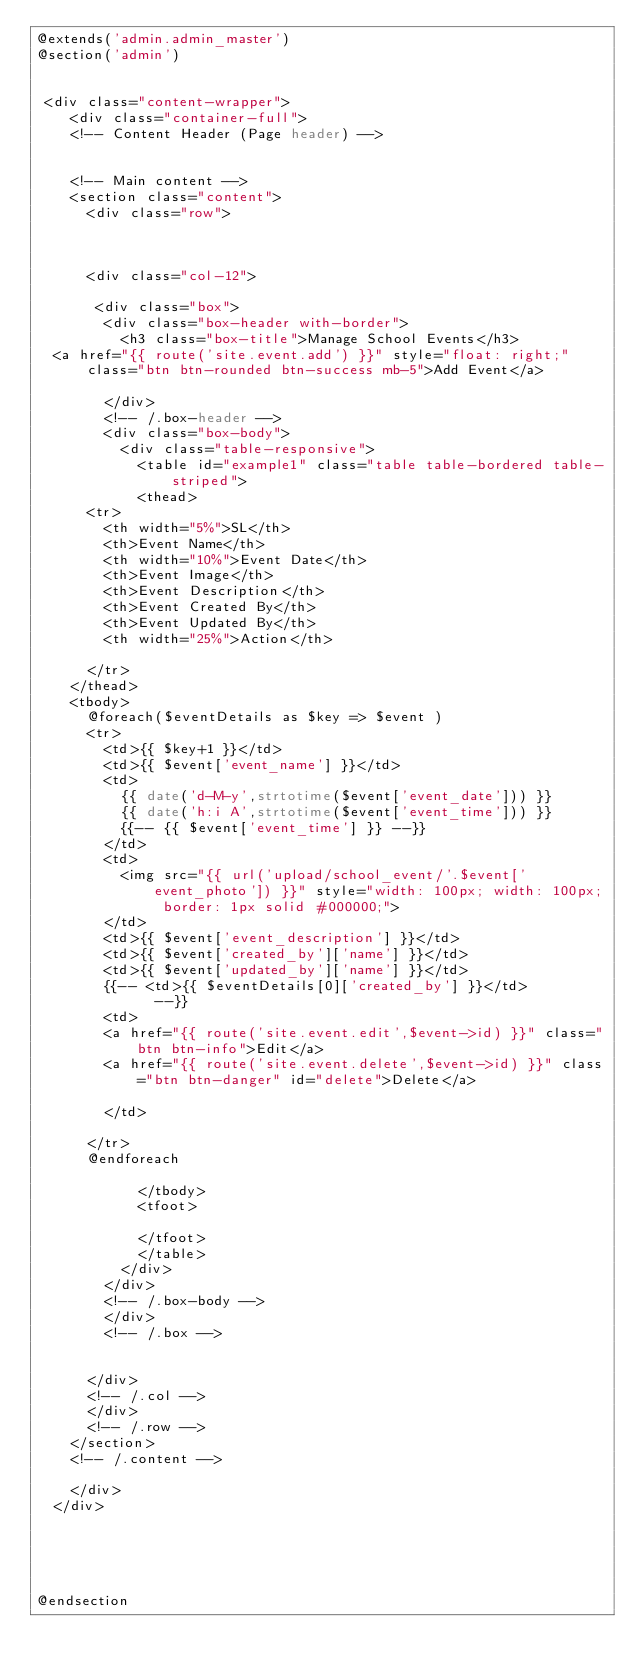Convert code to text. <code><loc_0><loc_0><loc_500><loc_500><_PHP_>@extends('admin.admin_master')
@section('admin')


 <div class="content-wrapper">
	  <div class="container-full">
		<!-- Content Header (Page header) -->
		 

		<!-- Main content -->
		<section class="content">
		  <div class="row">
			  
			 

			<div class="col-12">

			 <div class="box">
				<div class="box-header with-border">
				  <h3 class="box-title">Manage School Events</h3>
	<a href="{{ route('site.event.add') }}" style="float: right;" class="btn btn-rounded btn-success mb-5">Add Event</a>			  

				</div>
				<!-- /.box-header -->
				<div class="box-body">
					<div class="table-responsive">
					  <table id="example1" class="table table-bordered table-striped">
						<thead>
			<tr>
				<th width="5%">SL</th>  
				<th>Event Name</th> 
				<th width="10%">Event Date</th> 
				<th>Event Image</th> 
				<th>Event Description</th> 
				<th>Event Created By</th> 
				<th>Event Updated By</th> 
				<th width="25%">Action</th>
				 
			</tr>
		</thead>
		<tbody>
			@foreach($eventDetails as $key => $event )
			<tr>
				<td>{{ $key+1 }}</td>
				<td>{{ $event['event_name'] }}</td>
				<td>
					{{ date('d-M-y',strtotime($event['event_date'])) }}
					{{ date('h:i A',strtotime($event['event_time'])) }}
					{{-- {{ $event['event_time'] }} --}}
				</td>
				<td>
					<img src="{{ url('upload/school_event/'.$event['event_photo']) }}" style="width: 100px; width: 100px; border: 1px solid #000000;">
				</td>
				<td>{{ $event['event_description'] }}</td>
				<td>{{ $event['created_by']['name'] }}</td>
				<td>{{ $event['updated_by']['name'] }}</td>
				{{-- <td>{{ $eventDetails[0]['created_by'] }}</td>				  --}}
				<td>
				<a href="{{ route('site.event.edit',$event->id) }}" class="btn btn-info">Edit</a>
				<a href="{{ route('site.event.delete',$event->id) }}" class="btn btn-danger" id="delete">Delete</a>

				</td>
				 
			</tr>
			@endforeach
							 
						</tbody>
						<tfoot>
							 
						</tfoot>
					  </table>
					</div>
				</div>
				<!-- /.box-body -->
			  </div>
			  <!-- /.box -->

			       
			</div>
			<!-- /.col -->
		  </div>
		  <!-- /.row -->
		</section>
		<!-- /.content -->
	  
	  </div>
  </div>





@endsection
</code> 